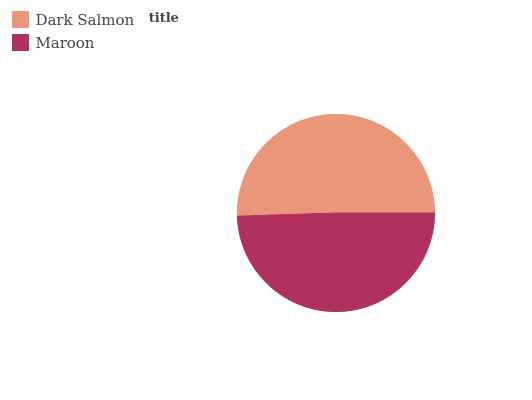Is Maroon the minimum?
Answer yes or no. Yes. Is Dark Salmon the maximum?
Answer yes or no. Yes. Is Maroon the maximum?
Answer yes or no. No. Is Dark Salmon greater than Maroon?
Answer yes or no. Yes. Is Maroon less than Dark Salmon?
Answer yes or no. Yes. Is Maroon greater than Dark Salmon?
Answer yes or no. No. Is Dark Salmon less than Maroon?
Answer yes or no. No. Is Dark Salmon the high median?
Answer yes or no. Yes. Is Maroon the low median?
Answer yes or no. Yes. Is Maroon the high median?
Answer yes or no. No. Is Dark Salmon the low median?
Answer yes or no. No. 